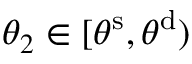<formula> <loc_0><loc_0><loc_500><loc_500>\theta _ { 2 } \in [ \theta ^ { s } , \theta ^ { d } )</formula> 